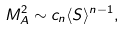<formula> <loc_0><loc_0><loc_500><loc_500>M _ { A } ^ { 2 } \sim c _ { n } \langle S \rangle ^ { n - 1 } ,</formula> 